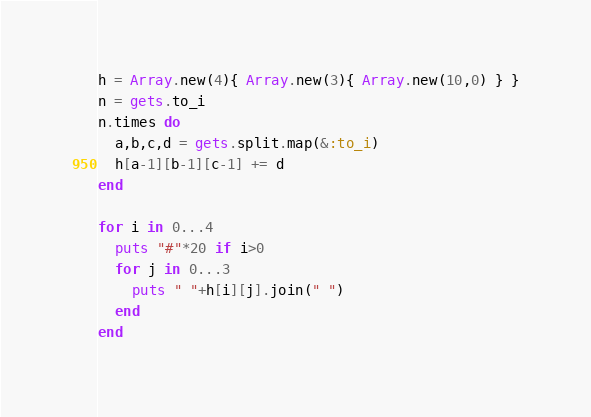<code> <loc_0><loc_0><loc_500><loc_500><_Ruby_>h = Array.new(4){ Array.new(3){ Array.new(10,0) } }
n = gets.to_i
n.times do
  a,b,c,d = gets.split.map(&:to_i)
  h[a-1][b-1][c-1] += d
end
 
for i in 0...4
  puts "#"*20 if i>0
  for j in 0...3
    puts " "+h[i][j].join(" ")     
  end
end
</code> 